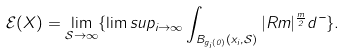Convert formula to latex. <formula><loc_0><loc_0><loc_500><loc_500>\mathcal { E } ( X ) = \lim _ { \mathcal { S } \to \infty } \{ \lim s u p _ { i \to \infty } \int _ { B _ { g _ { i } ( 0 ) } ( x _ { i } , \mathcal { S } ) } | R m | ^ { \frac { m } { 2 } } d \mu \} .</formula> 